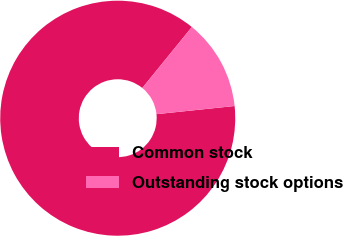Convert chart. <chart><loc_0><loc_0><loc_500><loc_500><pie_chart><fcel>Common stock<fcel>Outstanding stock options<nl><fcel>87.52%<fcel>12.48%<nl></chart> 